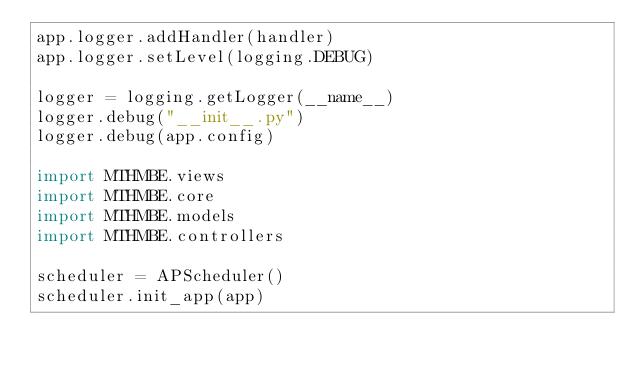Convert code to text. <code><loc_0><loc_0><loc_500><loc_500><_Python_>app.logger.addHandler(handler)
app.logger.setLevel(logging.DEBUG)

logger = logging.getLogger(__name__)
logger.debug("__init__.py")
logger.debug(app.config)

import MTHMBE.views
import MTHMBE.core
import MTHMBE.models
import MTHMBE.controllers

scheduler = APScheduler()
scheduler.init_app(app)




</code> 